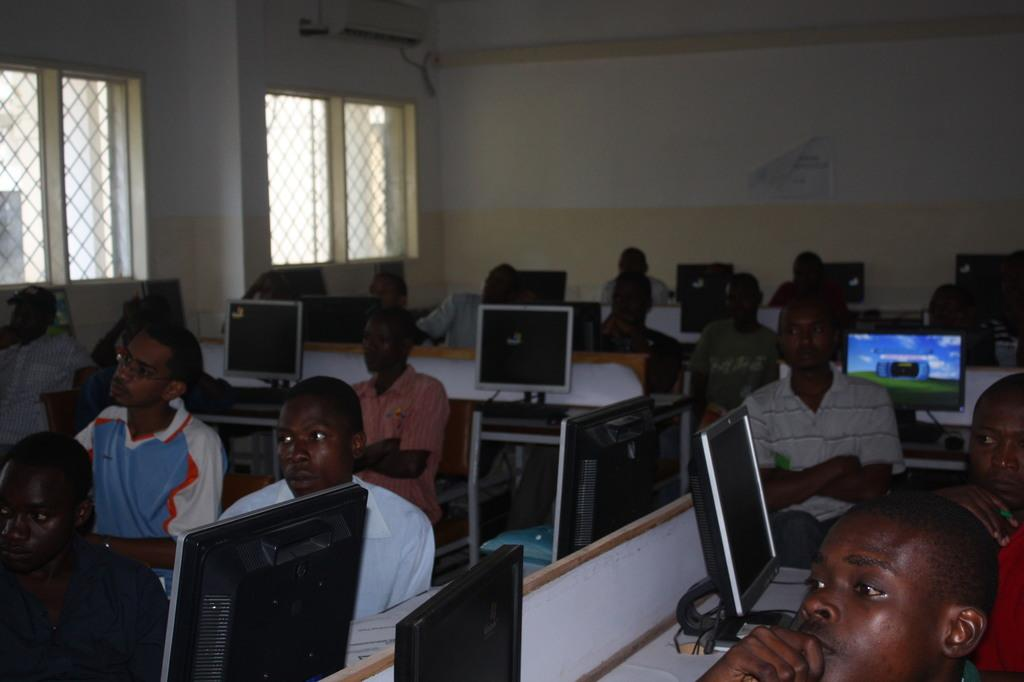What are the people in the image doing? The people in the image are sitting on chairs. What can be seen on the tables in the image? There are monitors on the tables in the image. What other objects are present in the image? There are other objects in the image, but their specific details are not mentioned in the facts. What is visible in the background of the image? In the background of the image, there are windows, a poster, and a wall. What type of wound can be seen on the poster in the background of the image? There is no wound visible on the poster in the background of the image. What effect does the connection between the chairs and the tables have on the people in the image? There is no mention of a connection between the chairs and the tables in the image, so it is not possible to determine any effect on the people. 